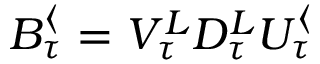Convert formula to latex. <formula><loc_0><loc_0><loc_500><loc_500>B _ { \tau } ^ { \langle } = V _ { \tau } ^ { L } D _ { \tau } ^ { L } U _ { \tau } ^ { \langle }</formula> 